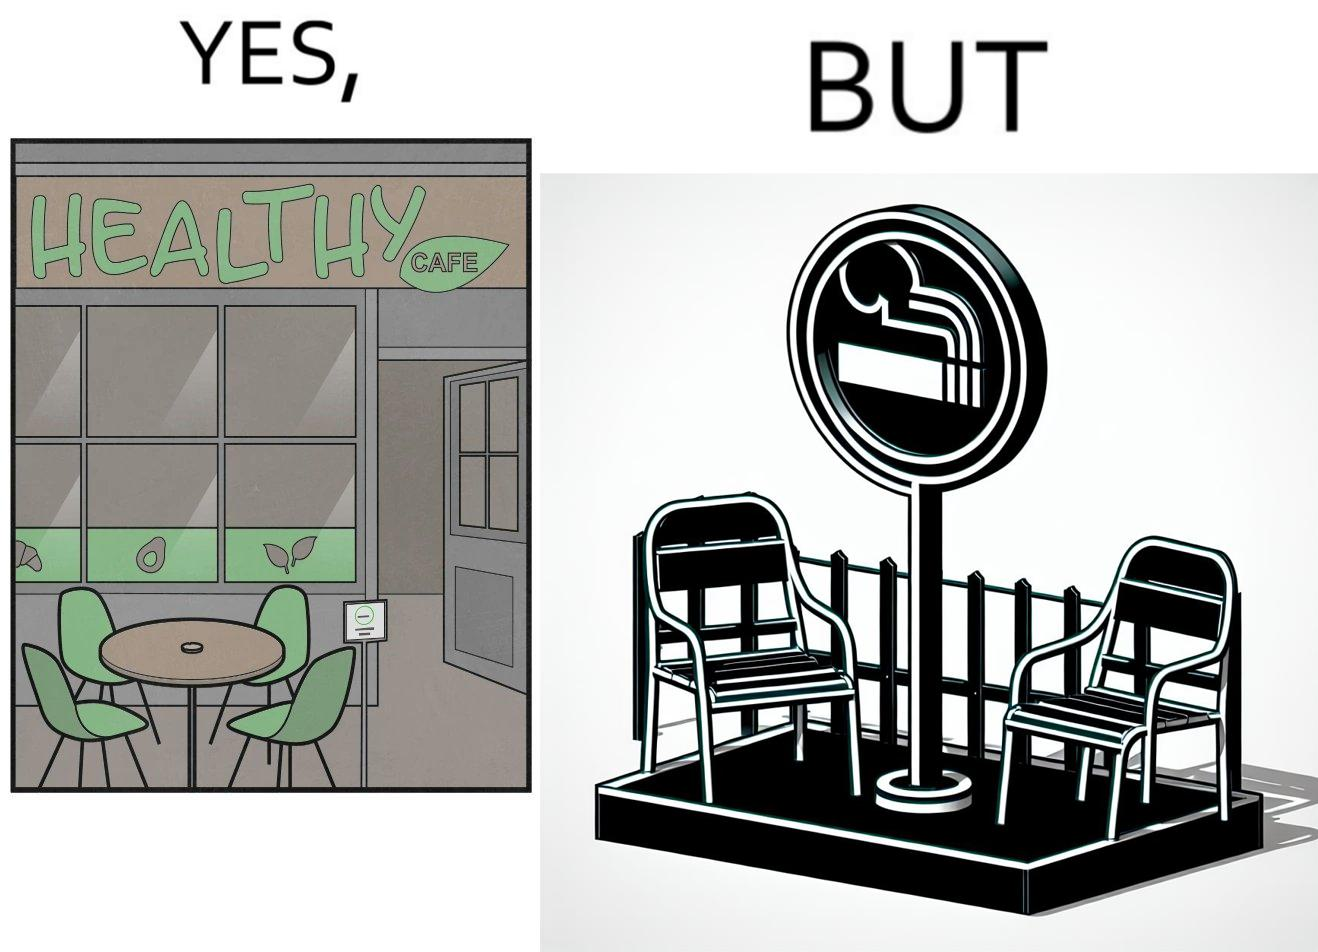What does this image depict? This image is funny because an eatery that calls itself the "healthy" cafe also has a smoking area, which is not very "healthy". If it really was a healthy cafe, it would not have a smoking area as smoking is injurious to health. Satire on the behavior of humans - both those that operate this cafe who made the decision of allowing smoking and creating a designated smoking area, and those that visit this healthy cafe to become "healthy", but then also indulge in very unhealthy habits simultaneously. 